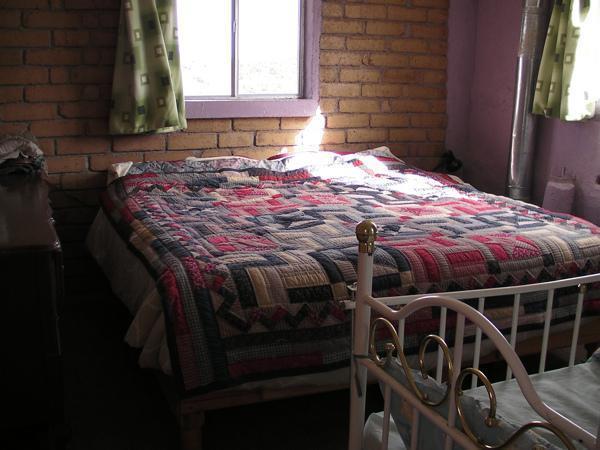How many beds are there?
Give a very brief answer. 2. 